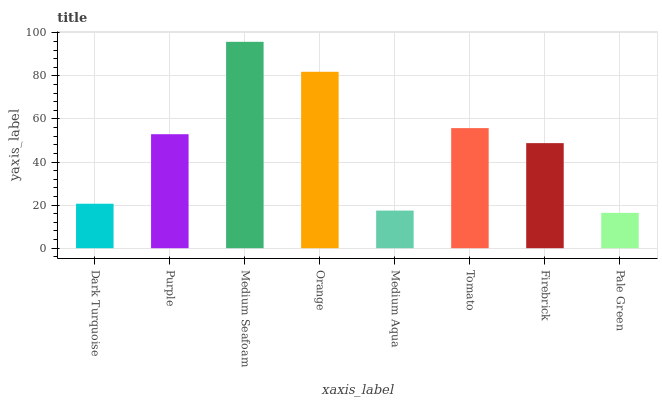Is Pale Green the minimum?
Answer yes or no. Yes. Is Medium Seafoam the maximum?
Answer yes or no. Yes. Is Purple the minimum?
Answer yes or no. No. Is Purple the maximum?
Answer yes or no. No. Is Purple greater than Dark Turquoise?
Answer yes or no. Yes. Is Dark Turquoise less than Purple?
Answer yes or no. Yes. Is Dark Turquoise greater than Purple?
Answer yes or no. No. Is Purple less than Dark Turquoise?
Answer yes or no. No. Is Purple the high median?
Answer yes or no. Yes. Is Firebrick the low median?
Answer yes or no. Yes. Is Firebrick the high median?
Answer yes or no. No. Is Purple the low median?
Answer yes or no. No. 